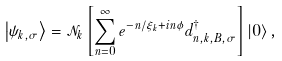<formula> <loc_0><loc_0><loc_500><loc_500>\left | \psi _ { k , \sigma } \right > = \mathcal { N } _ { k } \left [ \sum _ { n = 0 } ^ { \infty } e ^ { - n / \xi _ { k } + i n \phi } d _ { n , k , B , \sigma } ^ { \dagger } \right ] \left | 0 \right > ,</formula> 